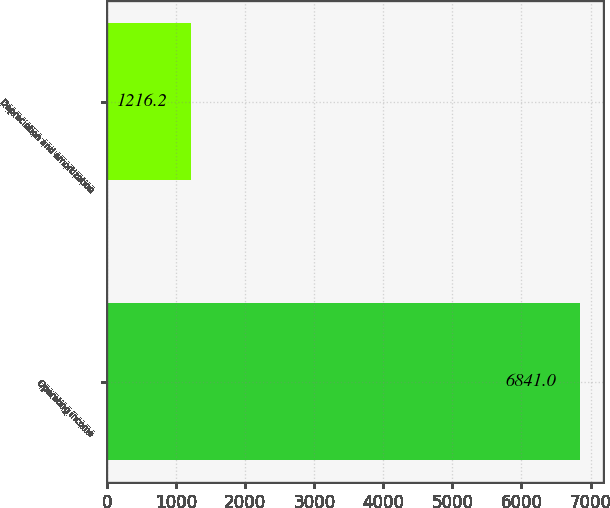Convert chart. <chart><loc_0><loc_0><loc_500><loc_500><bar_chart><fcel>Operating income<fcel>Depreciation and amortization<nl><fcel>6841<fcel>1216.2<nl></chart> 